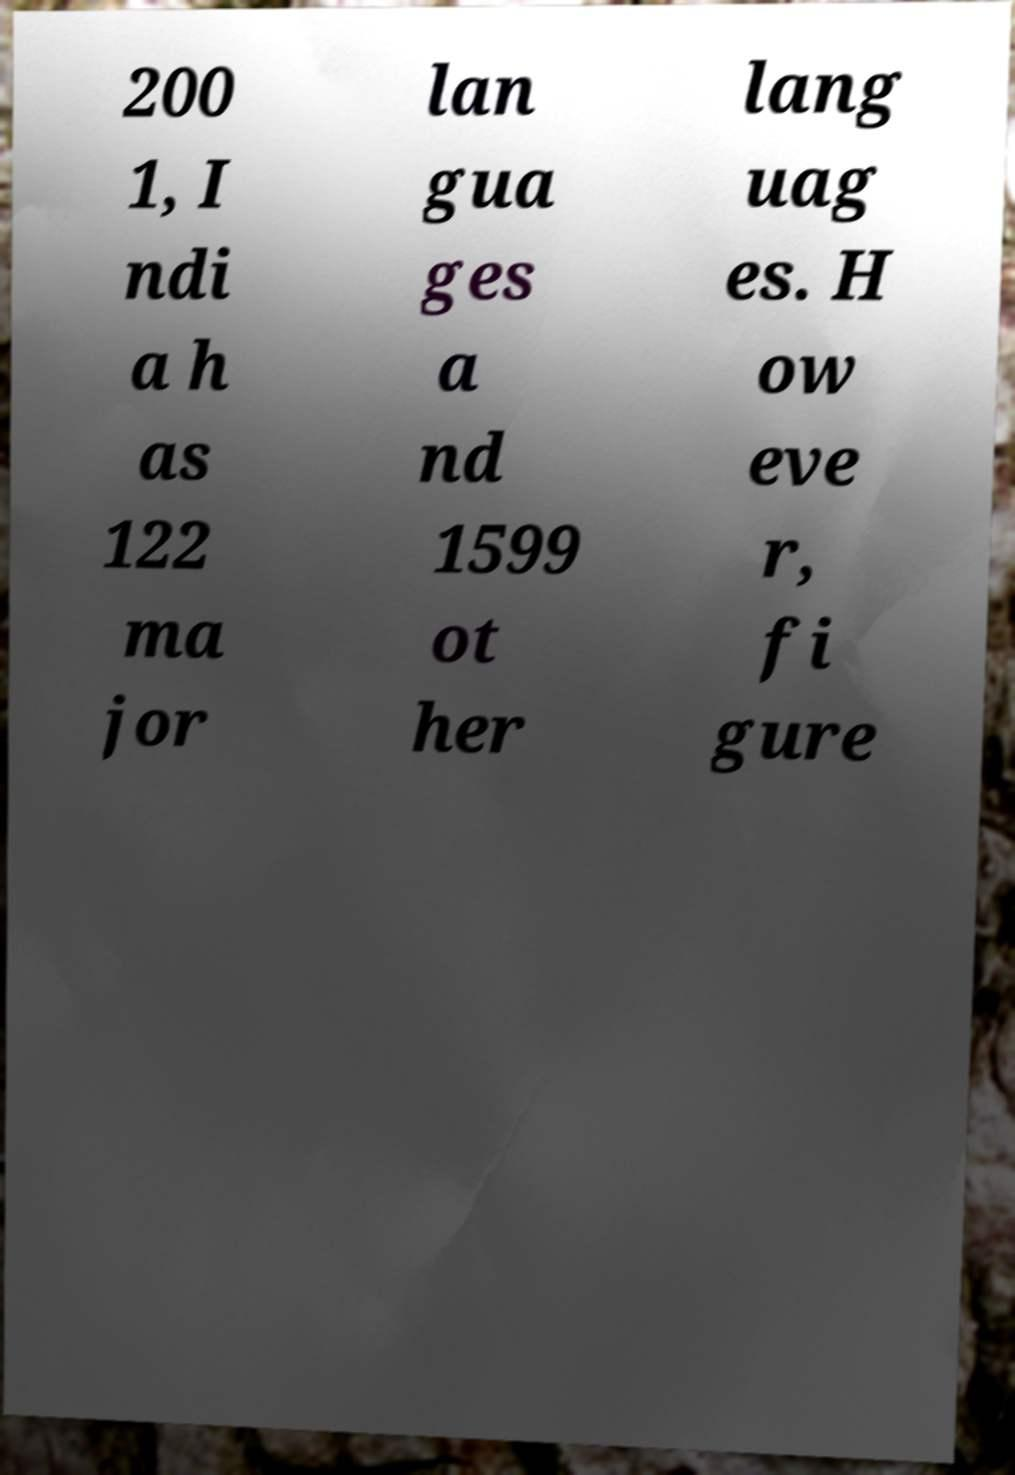There's text embedded in this image that I need extracted. Can you transcribe it verbatim? 200 1, I ndi a h as 122 ma jor lan gua ges a nd 1599 ot her lang uag es. H ow eve r, fi gure 